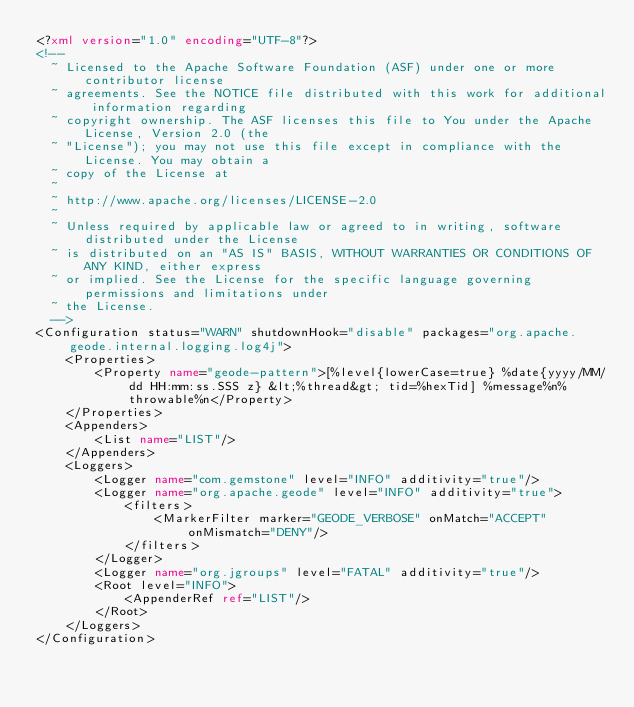Convert code to text. <code><loc_0><loc_0><loc_500><loc_500><_XML_><?xml version="1.0" encoding="UTF-8"?>
<!--
  ~ Licensed to the Apache Software Foundation (ASF) under one or more contributor license
  ~ agreements. See the NOTICE file distributed with this work for additional information regarding
  ~ copyright ownership. The ASF licenses this file to You under the Apache License, Version 2.0 (the
  ~ "License"); you may not use this file except in compliance with the License. You may obtain a
  ~ copy of the License at
  ~
  ~ http://www.apache.org/licenses/LICENSE-2.0
  ~
  ~ Unless required by applicable law or agreed to in writing, software distributed under the License
  ~ is distributed on an "AS IS" BASIS, WITHOUT WARRANTIES OR CONDITIONS OF ANY KIND, either express
  ~ or implied. See the License for the specific language governing permissions and limitations under
  ~ the License.
  -->
<Configuration status="WARN" shutdownHook="disable" packages="org.apache.geode.internal.logging.log4j">
    <Properties>
        <Property name="geode-pattern">[%level{lowerCase=true} %date{yyyy/MM/dd HH:mm:ss.SSS z} &lt;%thread&gt; tid=%hexTid] %message%n%throwable%n</Property>
    </Properties>
    <Appenders>
        <List name="LIST"/>
    </Appenders>
    <Loggers>
        <Logger name="com.gemstone" level="INFO" additivity="true"/>
        <Logger name="org.apache.geode" level="INFO" additivity="true">
            <filters>
                <MarkerFilter marker="GEODE_VERBOSE" onMatch="ACCEPT" onMismatch="DENY"/>
            </filters>
        </Logger>
        <Logger name="org.jgroups" level="FATAL" additivity="true"/>
        <Root level="INFO">
            <AppenderRef ref="LIST"/>
        </Root>
    </Loggers>
</Configuration>
</code> 